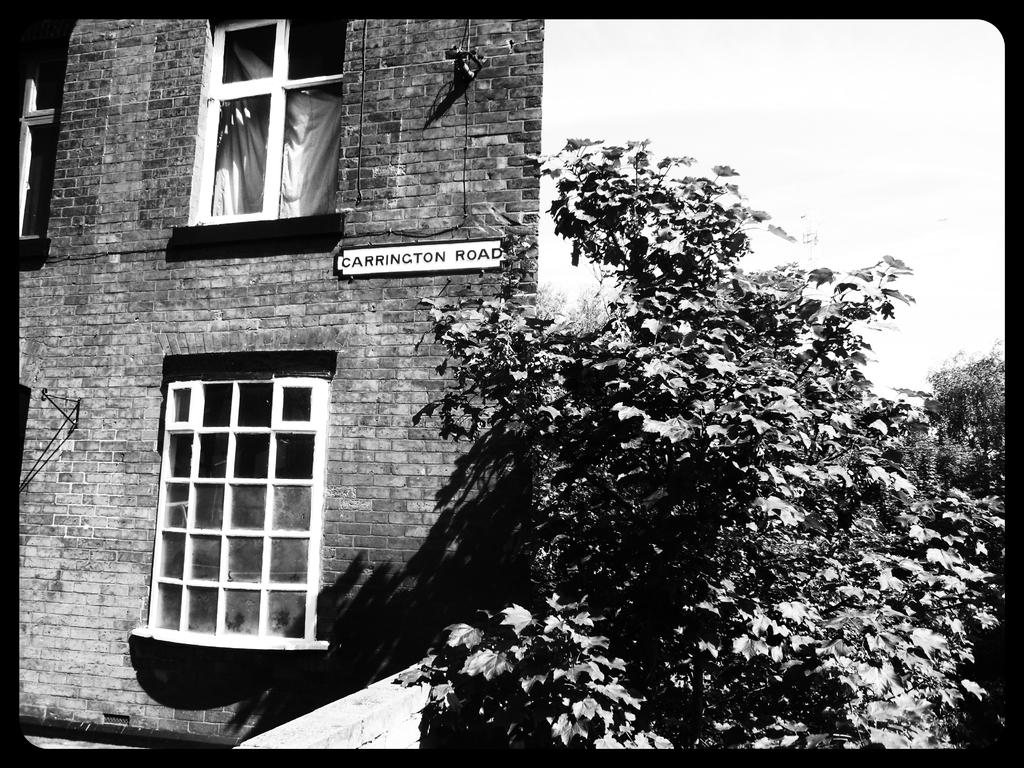What is the color scheme of the image? The image is black and white. What structure can be seen in the image? There is a house in the image. What features can be observed on the house? The house has windows. What type of vegetation is present in the image? There are plants and trees in the image. What is the condition of the sky in the image? The sky is clear in the image. Can you tell me how many people are swimming in the image? There is no swimming or people present in the image; it features a house, plants, trees, and a clear sky. What type of fork is being used to trim the trees in the image? There is no fork or tree-trimming activity depicted in the image. 